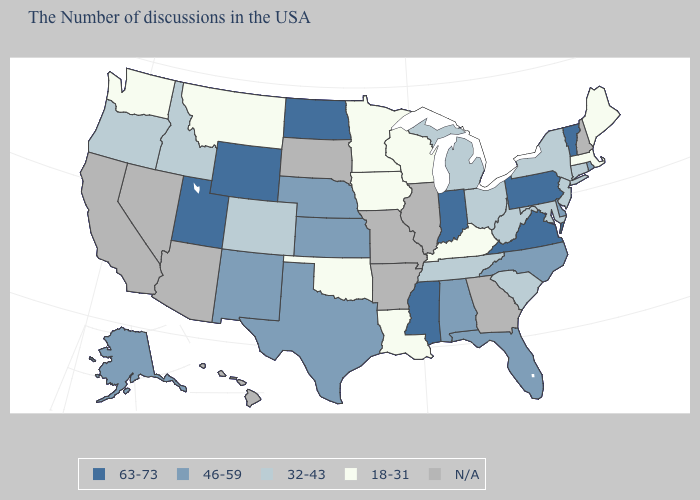Which states have the lowest value in the USA?
Give a very brief answer. Maine, Massachusetts, Kentucky, Wisconsin, Louisiana, Minnesota, Iowa, Oklahoma, Montana, Washington. Name the states that have a value in the range 63-73?
Keep it brief. Vermont, Pennsylvania, Virginia, Indiana, Mississippi, North Dakota, Wyoming, Utah. What is the value of Idaho?
Short answer required. 32-43. What is the value of Missouri?
Be succinct. N/A. Does the first symbol in the legend represent the smallest category?
Concise answer only. No. What is the value of Kansas?
Concise answer only. 46-59. Name the states that have a value in the range 18-31?
Give a very brief answer. Maine, Massachusetts, Kentucky, Wisconsin, Louisiana, Minnesota, Iowa, Oklahoma, Montana, Washington. Among the states that border Iowa , does Wisconsin have the lowest value?
Keep it brief. Yes. What is the value of Washington?
Give a very brief answer. 18-31. Which states have the lowest value in the South?
Keep it brief. Kentucky, Louisiana, Oklahoma. What is the lowest value in states that border Minnesota?
Short answer required. 18-31. What is the value of Georgia?
Give a very brief answer. N/A. Name the states that have a value in the range 32-43?
Concise answer only. Connecticut, New York, New Jersey, Maryland, South Carolina, West Virginia, Ohio, Michigan, Tennessee, Colorado, Idaho, Oregon. Among the states that border Idaho , does Oregon have the highest value?
Quick response, please. No. What is the lowest value in the USA?
Short answer required. 18-31. 